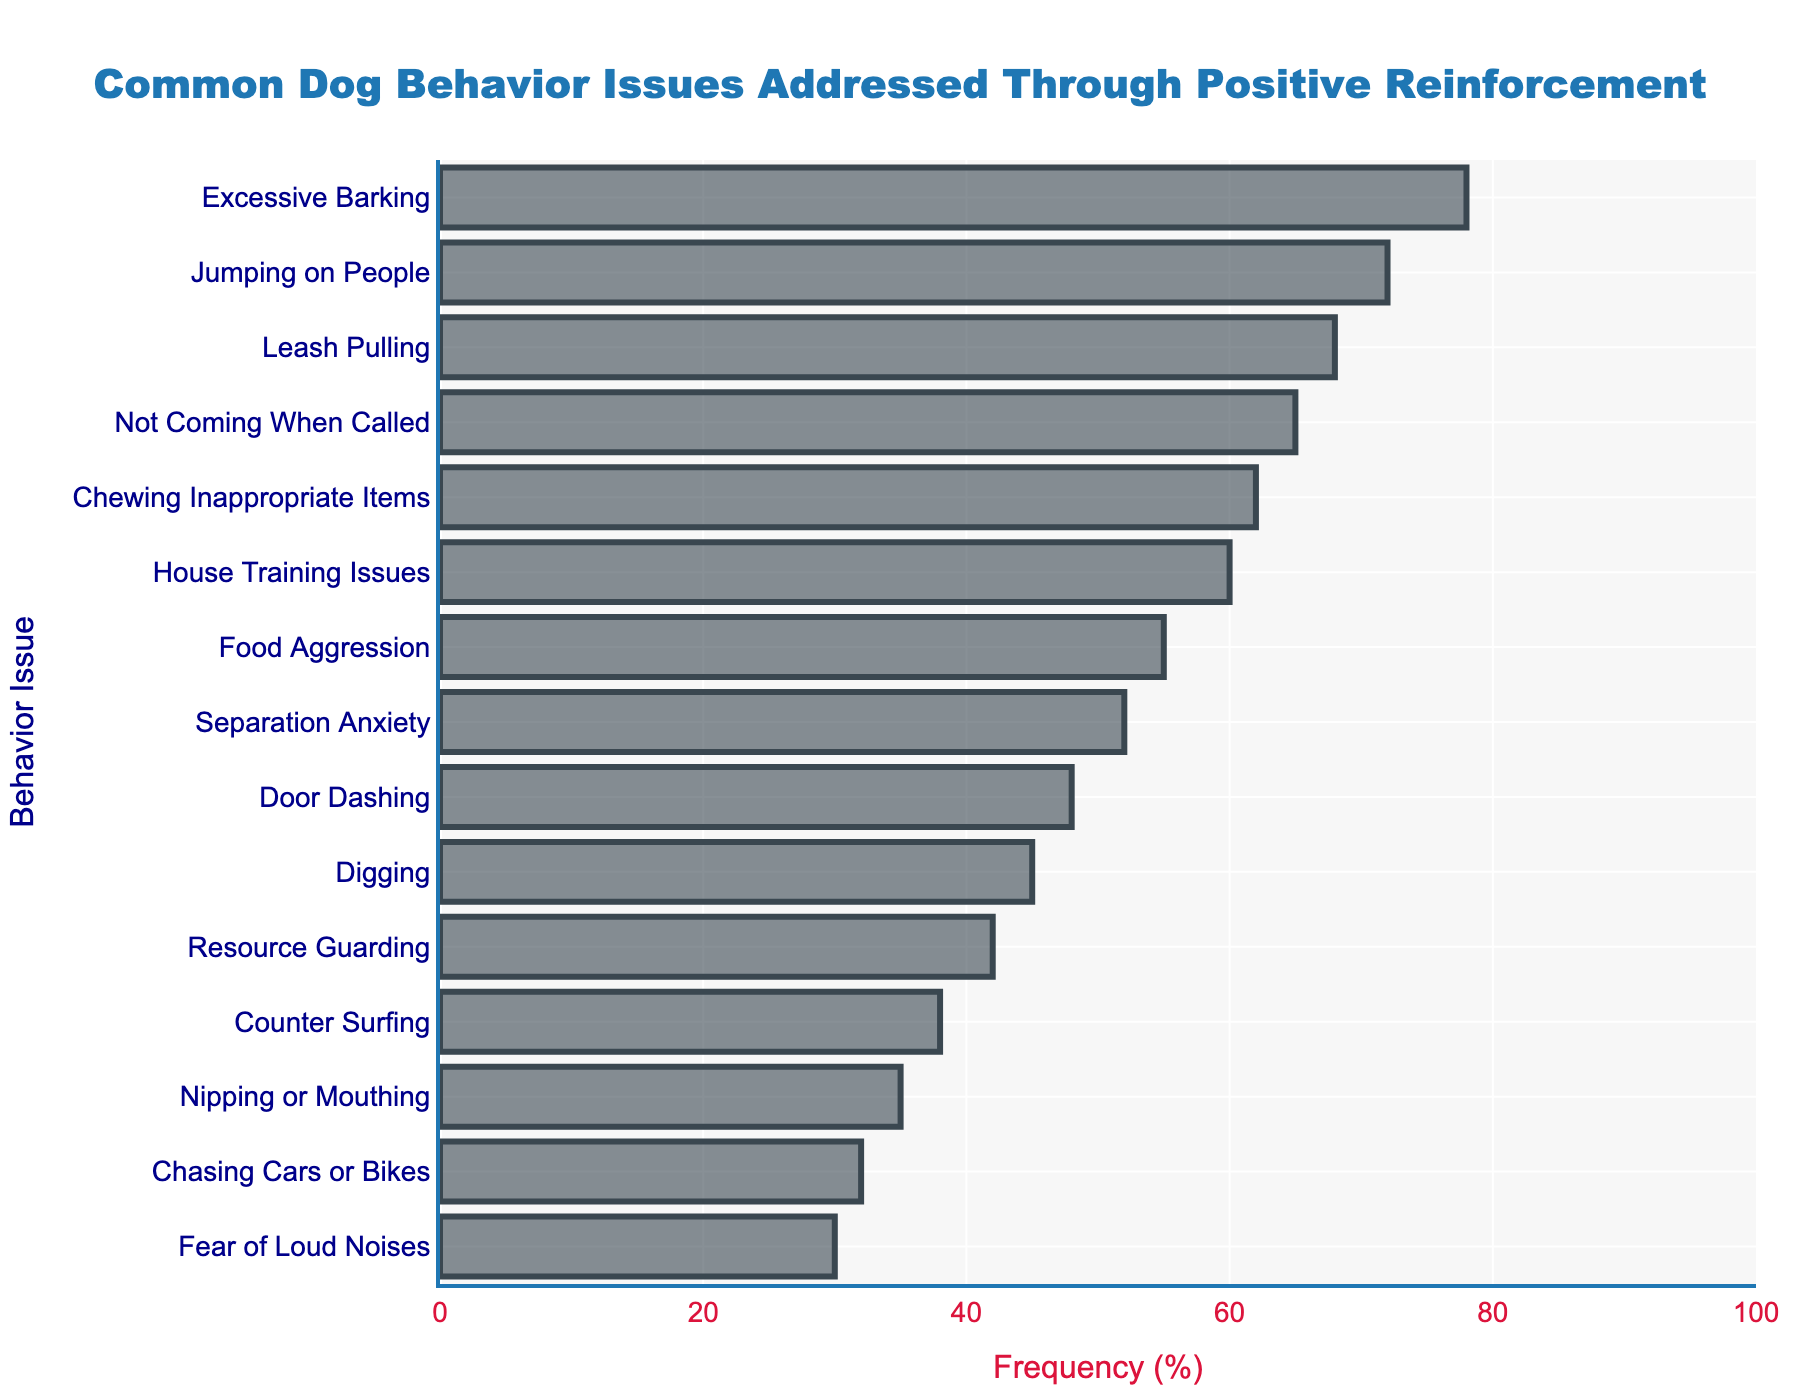Which behavior issue has the highest frequency addressed through positive reinforcement? Look at the figure to see which bar extends the farthest to the right since a longer bar represents a higher frequency.
Answer: Excessive Barking Which two behavior issues have similar frequencies, around 60%? Look at the figure and identify bars that end near the 60% mark.
Answer: House Training Issues and Chewing Inappropriate Items What is the combined frequency of the three most common dog behavior issues addressed through positive reinforcement? The three longest bars represent the most common issues: Excessive Barking (78%), Jumping on People (72%), and Leash Pulling (68%). Add their frequencies: 78 + 72 + 68 = 218.
Answer: 218 Which behavior issue has a lower frequency, "House Training Issues" or "Separation Anxiety"? Compare the lengths of the bars for "House Training Issues" and "Separation Anxiety." The former ends at 60%, and the latter ends at 52%.
Answer: Separation Anxiety What is the average frequency of the top five behavior issues? The top five issues are Excessive Barking (78%), Jumping on People (72%), Leash Pulling (68%), Not Coming When Called (65%), and Chewing Inappropriate Items (62%). Calculate the average: (78 + 72 + 68 + 65 + 62) / 5 = 69.
Answer: 69 Which behavior issue has the lowest frequency addressed through positive reinforcement? Look at the figure to see which bar extends the least to the right since a shorter bar represents a lower frequency.
Answer: Fear of Loud Noises By how much does the frequency of "Jumping on People" exceed the frequency of "Digging"? Find the frequencies of "Jumping on People" (72%) and "Digging" (45%) and subtract the former from the latter: 72 - 45 = 27.
Answer: 27 How does the frequency of "Counter Surfing" compare to "Resource Guarding"? Compare the lengths of the bars for "Counter Surfing" and "Resource Guarding." The former ends at 38%, and the latter ends at 42%.
Answer: Resource Guarding is higher Which two behavior issues have frequencies below 35%? Identify the bars that end lower than the 35% mark: "Chasing Cars or Bikes" (32%) and "Fear of Loud Noises" (30%).
Answer: Chasing Cars or Bikes and Fear of Loud Noises What is the difference in frequency between "Food Aggression" and "Not Coming When Called"? Find the frequencies of "Food Aggression" (55%) and "Not Coming When Called" (65%) and subtract the latter from the former: 65 - 55 = 10.
Answer: 10 